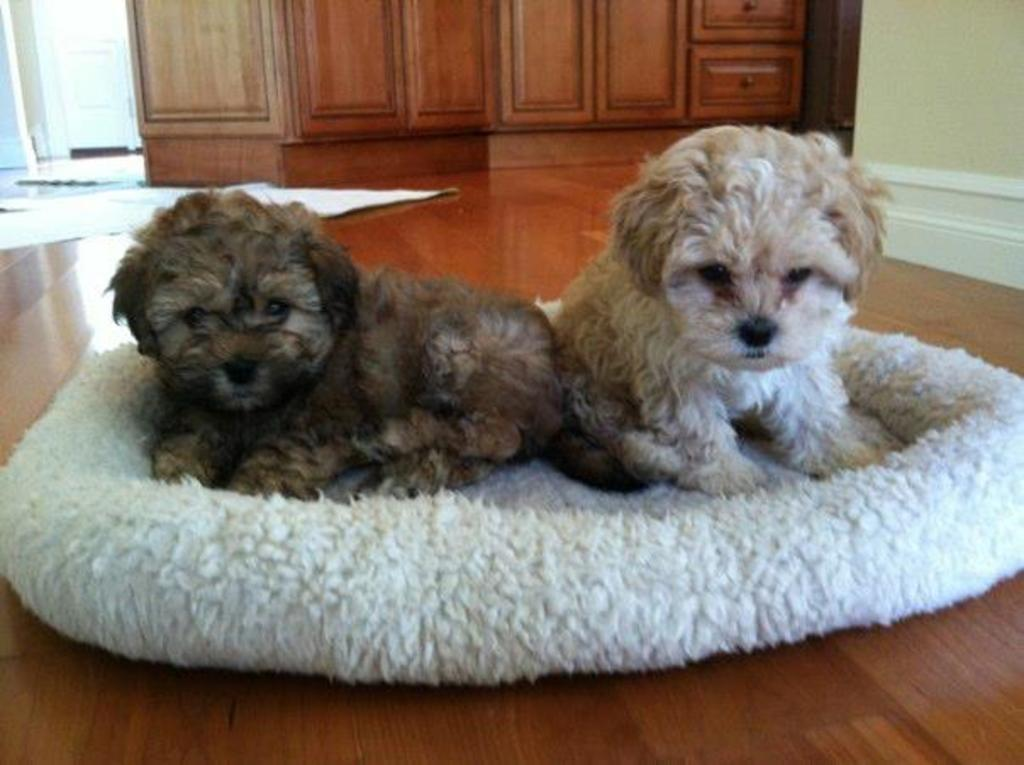What animals are on the floor in the image? There are dogs on the floor in the image. What can be seen behind the dogs? There is a wall visible in the image. What type of furniture is present in the background of the image? There are cupboards in the background of the image. What type of floor covering is present in the background of the image? There are mats in the background of the image. What type of hair is visible on the dogs in the image? The image does not show the dogs' hair; it only shows their bodies. What type of birthday celebration is taking place in the image? There is no birthday celebration present in the image. 